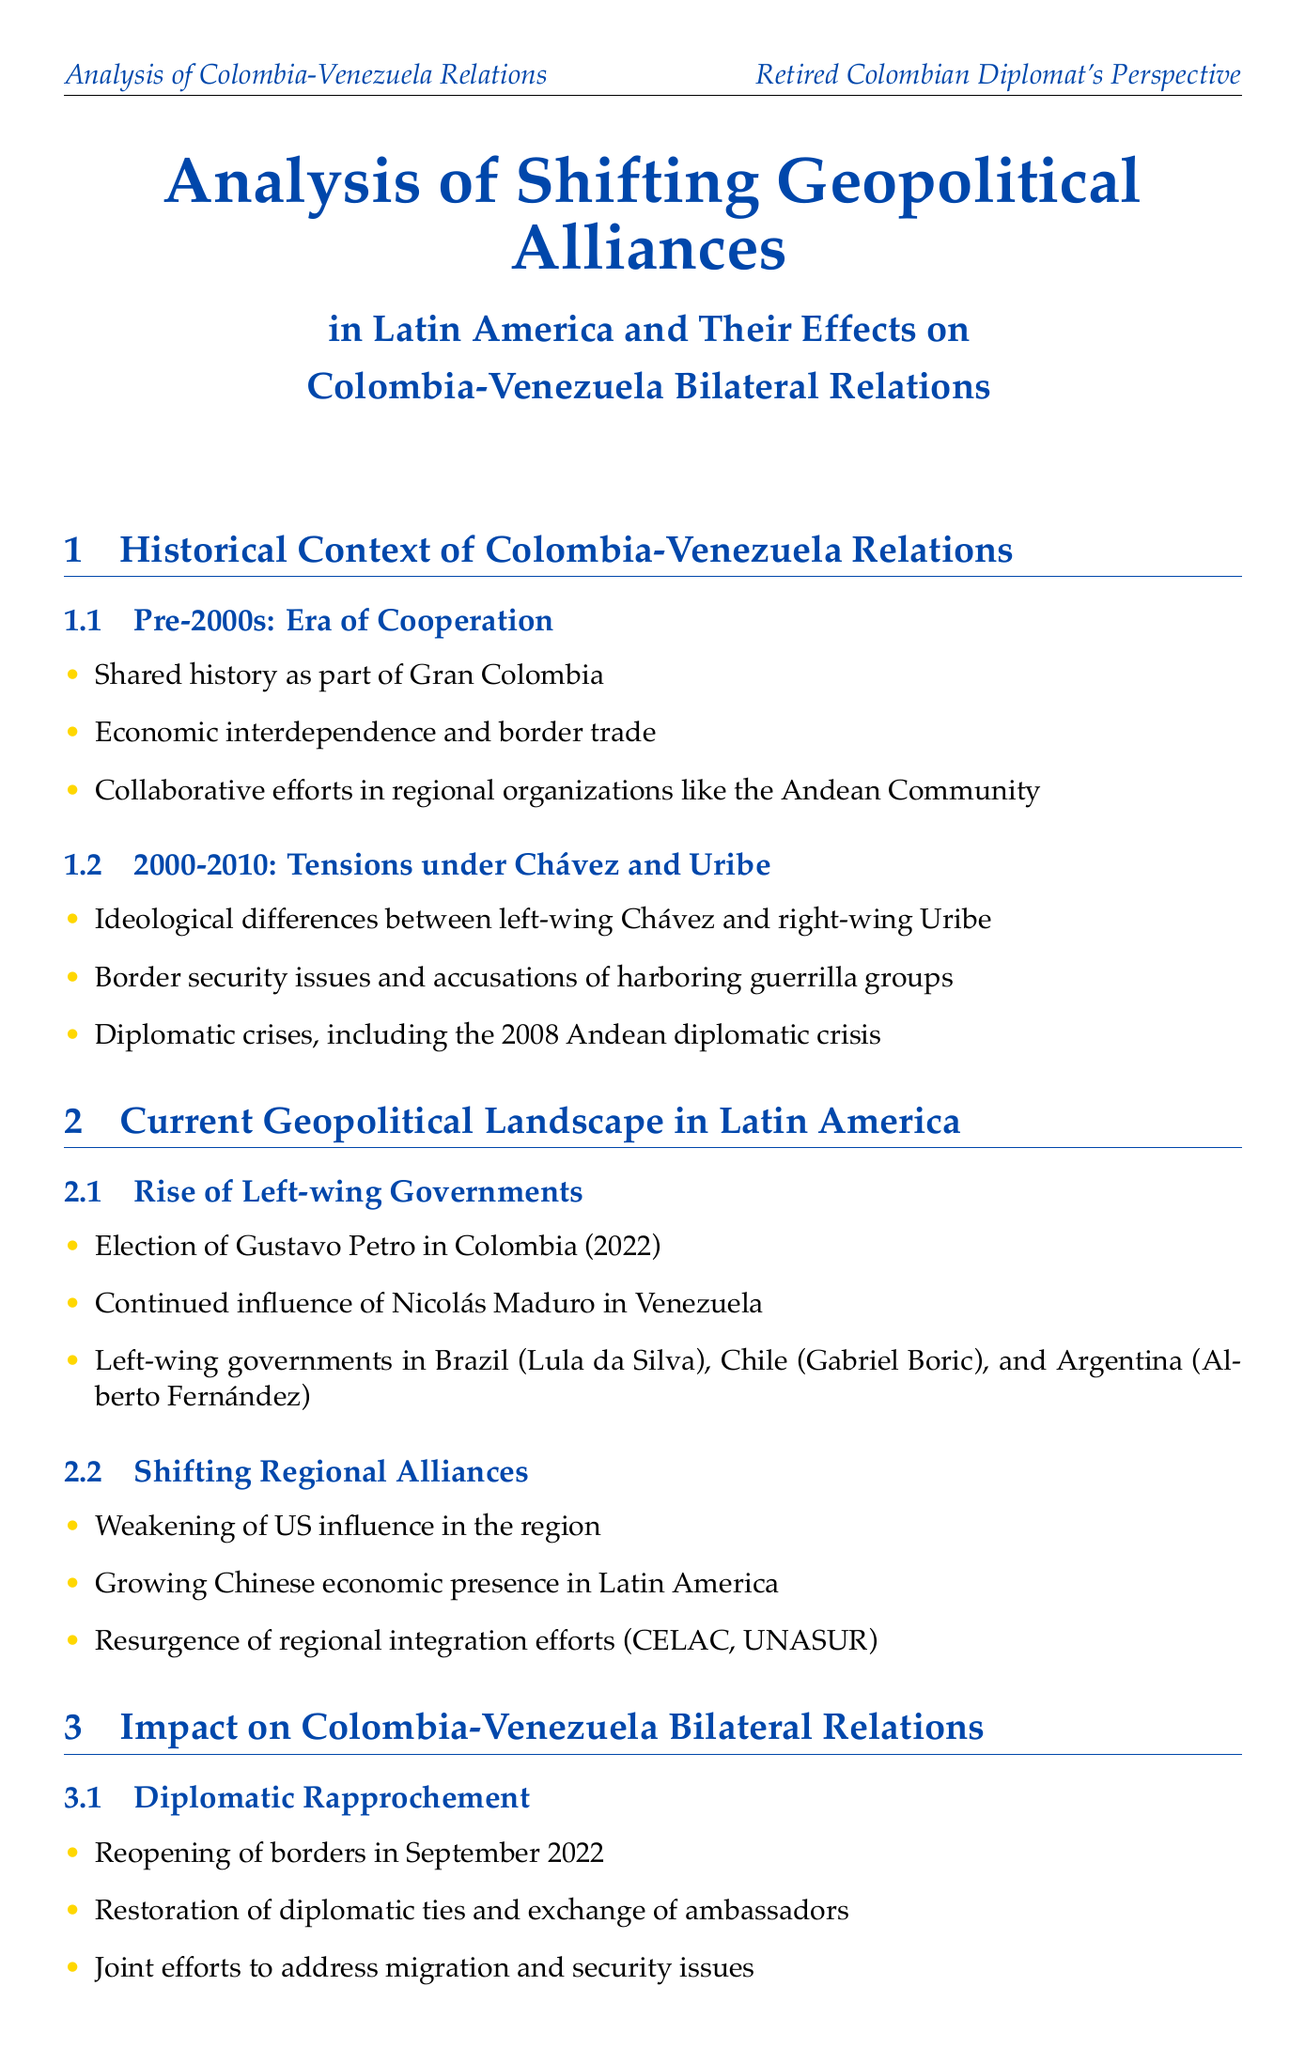What was the era of cooperation in Colombia-Venezuela relations? The document lists the pre-2000s as the era of cooperation, highlighting shared history and economic interdependence.
Answer: Pre-2000s: Era of Cooperation Who are the key figures in the Colombia-Venezuela diplomatic rapprochement? The document names four key figures, including Gustavo Petro and Nicolás Maduro, who play significant roles in the bilateral relationship.
Answer: Gustavo Petro, Nicolás Maduro, Álvaro Leyva Durán, Carlos Faría When did Colombia reopen its border with Venezuela? The document specifies the date of the reopening of the border as a significant step toward normalization.
Answer: September 26, 2022 What is the importance of CELAC mentioned in the document? CELAC is described as a forum for regional dialogue excluding the US and Canada, highlighting its relevance in the geopolitical landscape.
Answer: Forum for regional dialogue excluding the US and Canada What challenges does the document identify in Colombia-Venezuela relations? The document lists several persistent issues affecting the bilateral relationship, including Venezuela's economic crisis and management of guerrilla groups.
Answer: Venezuela's ongoing political and economic crisis How did the election of Gustavo Petro impact Colombia's foreign policy? The document marks his inauguration in 2022 as a key moment that shifted Colombia's diplomatic approach towards Venezuela.
Answer: Shift in Colombia's foreign policy approach What recommendations does the report make for strengthening bilateral relations? The document suggests revitalizing the Colombia-Venezuela Binational Commission and establishing high-level diplomatic consultations.
Answer: Revitalization of the Colombia-Venezuela Binational Commission What significant event occurred on August 7, 2022? The document highlights this date as the inauguration of Gustavo Petro, which marked a shift in the foreign policy approach of Colombia.
Answer: Inauguration of Gustavo Petro as President of Colombia What has affected US influence in the region according to the report? The document indicates the weakening of US influence as one of the shifting regional dynamics impacting alliances.
Answer: Weakening of US influence in the region 